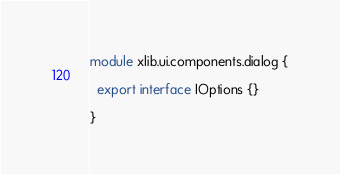<code> <loc_0><loc_0><loc_500><loc_500><_TypeScript_>module xlib.ui.components.dialog {

  export interface IOptions {}

}</code> 